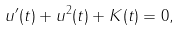<formula> <loc_0><loc_0><loc_500><loc_500>u ^ { \prime } ( t ) + u ^ { 2 } ( t ) + K ( t ) = 0 ,</formula> 